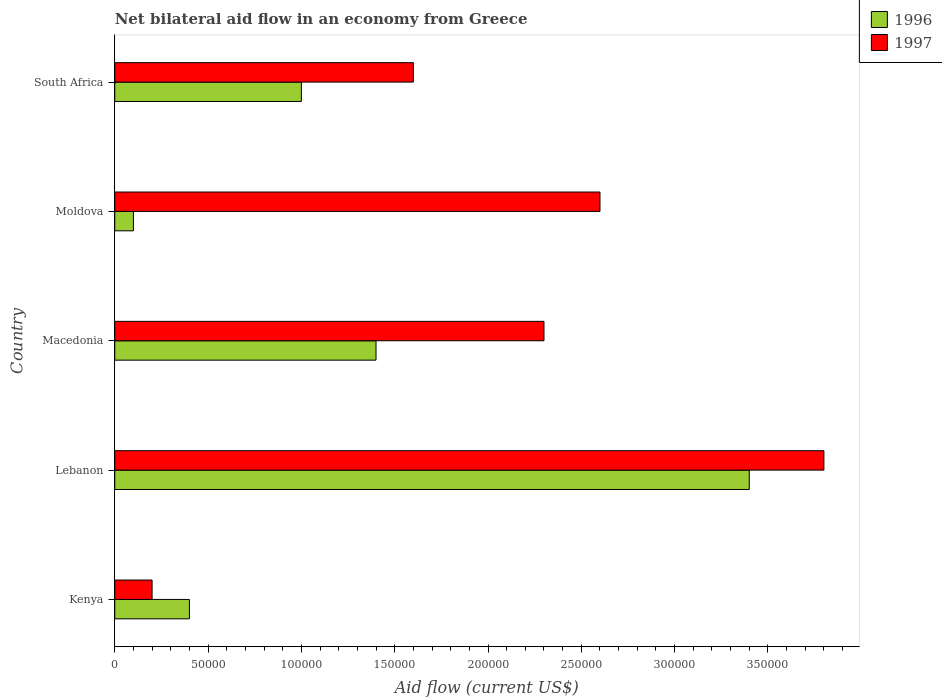How many groups of bars are there?
Your answer should be compact. 5. Are the number of bars per tick equal to the number of legend labels?
Offer a very short reply. Yes. What is the label of the 5th group of bars from the top?
Your response must be concise. Kenya. Across all countries, what is the minimum net bilateral aid flow in 1997?
Your answer should be very brief. 2.00e+04. In which country was the net bilateral aid flow in 1996 maximum?
Keep it short and to the point. Lebanon. In which country was the net bilateral aid flow in 1997 minimum?
Provide a short and direct response. Kenya. What is the total net bilateral aid flow in 1996 in the graph?
Your response must be concise. 6.30e+05. What is the difference between the net bilateral aid flow in 1996 in Kenya and that in Lebanon?
Your response must be concise. -3.00e+05. What is the average net bilateral aid flow in 1996 per country?
Provide a short and direct response. 1.26e+05. What is the difference between the net bilateral aid flow in 1996 and net bilateral aid flow in 1997 in Kenya?
Your answer should be compact. 2.00e+04. What is the ratio of the net bilateral aid flow in 1996 in Lebanon to that in Macedonia?
Provide a short and direct response. 2.43. Is the difference between the net bilateral aid flow in 1996 in Kenya and South Africa greater than the difference between the net bilateral aid flow in 1997 in Kenya and South Africa?
Offer a very short reply. Yes. What is the difference between the highest and the lowest net bilateral aid flow in 1996?
Provide a short and direct response. 3.30e+05. How many bars are there?
Offer a terse response. 10. Are all the bars in the graph horizontal?
Your response must be concise. Yes. How many countries are there in the graph?
Make the answer very short. 5. What is the difference between two consecutive major ticks on the X-axis?
Offer a very short reply. 5.00e+04. What is the title of the graph?
Provide a short and direct response. Net bilateral aid flow in an economy from Greece. Does "2005" appear as one of the legend labels in the graph?
Make the answer very short. No. What is the label or title of the X-axis?
Provide a succinct answer. Aid flow (current US$). What is the Aid flow (current US$) in 1996 in Kenya?
Offer a terse response. 4.00e+04. What is the Aid flow (current US$) in 1997 in Kenya?
Make the answer very short. 2.00e+04. What is the Aid flow (current US$) of 1996 in Lebanon?
Keep it short and to the point. 3.40e+05. What is the Aid flow (current US$) in 1997 in Lebanon?
Offer a very short reply. 3.80e+05. What is the Aid flow (current US$) of 1996 in Macedonia?
Your answer should be compact. 1.40e+05. What is the Aid flow (current US$) in 1997 in Macedonia?
Make the answer very short. 2.30e+05. What is the Aid flow (current US$) in 1996 in South Africa?
Your response must be concise. 1.00e+05. Across all countries, what is the maximum Aid flow (current US$) in 1997?
Provide a short and direct response. 3.80e+05. What is the total Aid flow (current US$) of 1996 in the graph?
Your answer should be very brief. 6.30e+05. What is the total Aid flow (current US$) in 1997 in the graph?
Make the answer very short. 1.05e+06. What is the difference between the Aid flow (current US$) in 1996 in Kenya and that in Lebanon?
Your answer should be very brief. -3.00e+05. What is the difference between the Aid flow (current US$) in 1997 in Kenya and that in Lebanon?
Give a very brief answer. -3.60e+05. What is the difference between the Aid flow (current US$) of 1996 in Kenya and that in Macedonia?
Keep it short and to the point. -1.00e+05. What is the difference between the Aid flow (current US$) in 1997 in Kenya and that in Macedonia?
Your answer should be very brief. -2.10e+05. What is the difference between the Aid flow (current US$) in 1996 in Kenya and that in Moldova?
Give a very brief answer. 3.00e+04. What is the difference between the Aid flow (current US$) of 1996 in Kenya and that in South Africa?
Offer a very short reply. -6.00e+04. What is the difference between the Aid flow (current US$) in 1997 in Kenya and that in South Africa?
Give a very brief answer. -1.40e+05. What is the difference between the Aid flow (current US$) in 1996 in Lebanon and that in Macedonia?
Your answer should be compact. 2.00e+05. What is the difference between the Aid flow (current US$) of 1996 in Lebanon and that in Moldova?
Your response must be concise. 3.30e+05. What is the difference between the Aid flow (current US$) in 1997 in Lebanon and that in Moldova?
Your answer should be very brief. 1.20e+05. What is the difference between the Aid flow (current US$) in 1997 in Lebanon and that in South Africa?
Provide a short and direct response. 2.20e+05. What is the difference between the Aid flow (current US$) of 1996 in Macedonia and that in Moldova?
Make the answer very short. 1.30e+05. What is the difference between the Aid flow (current US$) in 1996 in Moldova and that in South Africa?
Offer a terse response. -9.00e+04. What is the difference between the Aid flow (current US$) of 1996 in Kenya and the Aid flow (current US$) of 1997 in Lebanon?
Provide a short and direct response. -3.40e+05. What is the difference between the Aid flow (current US$) of 1996 in Kenya and the Aid flow (current US$) of 1997 in Macedonia?
Your answer should be compact. -1.90e+05. What is the difference between the Aid flow (current US$) in 1996 in Kenya and the Aid flow (current US$) in 1997 in Moldova?
Keep it short and to the point. -2.20e+05. What is the difference between the Aid flow (current US$) of 1996 in Kenya and the Aid flow (current US$) of 1997 in South Africa?
Your answer should be very brief. -1.20e+05. What is the difference between the Aid flow (current US$) of 1996 in Lebanon and the Aid flow (current US$) of 1997 in Macedonia?
Give a very brief answer. 1.10e+05. What is the difference between the Aid flow (current US$) in 1996 in Lebanon and the Aid flow (current US$) in 1997 in Moldova?
Your answer should be compact. 8.00e+04. What is the difference between the Aid flow (current US$) of 1996 in Lebanon and the Aid flow (current US$) of 1997 in South Africa?
Your answer should be very brief. 1.80e+05. What is the difference between the Aid flow (current US$) in 1996 in Macedonia and the Aid flow (current US$) in 1997 in South Africa?
Make the answer very short. -2.00e+04. What is the difference between the Aid flow (current US$) in 1996 in Moldova and the Aid flow (current US$) in 1997 in South Africa?
Your answer should be compact. -1.50e+05. What is the average Aid flow (current US$) of 1996 per country?
Provide a short and direct response. 1.26e+05. What is the difference between the Aid flow (current US$) in 1996 and Aid flow (current US$) in 1997 in Kenya?
Your answer should be very brief. 2.00e+04. What is the difference between the Aid flow (current US$) of 1996 and Aid flow (current US$) of 1997 in Macedonia?
Ensure brevity in your answer.  -9.00e+04. What is the difference between the Aid flow (current US$) of 1996 and Aid flow (current US$) of 1997 in South Africa?
Keep it short and to the point. -6.00e+04. What is the ratio of the Aid flow (current US$) in 1996 in Kenya to that in Lebanon?
Your response must be concise. 0.12. What is the ratio of the Aid flow (current US$) in 1997 in Kenya to that in Lebanon?
Make the answer very short. 0.05. What is the ratio of the Aid flow (current US$) in 1996 in Kenya to that in Macedonia?
Give a very brief answer. 0.29. What is the ratio of the Aid flow (current US$) in 1997 in Kenya to that in Macedonia?
Make the answer very short. 0.09. What is the ratio of the Aid flow (current US$) of 1997 in Kenya to that in Moldova?
Your answer should be very brief. 0.08. What is the ratio of the Aid flow (current US$) of 1996 in Kenya to that in South Africa?
Your response must be concise. 0.4. What is the ratio of the Aid flow (current US$) in 1996 in Lebanon to that in Macedonia?
Your answer should be compact. 2.43. What is the ratio of the Aid flow (current US$) in 1997 in Lebanon to that in Macedonia?
Offer a terse response. 1.65. What is the ratio of the Aid flow (current US$) of 1997 in Lebanon to that in Moldova?
Keep it short and to the point. 1.46. What is the ratio of the Aid flow (current US$) of 1997 in Lebanon to that in South Africa?
Your answer should be compact. 2.38. What is the ratio of the Aid flow (current US$) in 1996 in Macedonia to that in Moldova?
Offer a terse response. 14. What is the ratio of the Aid flow (current US$) of 1997 in Macedonia to that in Moldova?
Keep it short and to the point. 0.88. What is the ratio of the Aid flow (current US$) of 1996 in Macedonia to that in South Africa?
Keep it short and to the point. 1.4. What is the ratio of the Aid flow (current US$) of 1997 in Macedonia to that in South Africa?
Your answer should be compact. 1.44. What is the ratio of the Aid flow (current US$) in 1997 in Moldova to that in South Africa?
Ensure brevity in your answer.  1.62. What is the difference between the highest and the second highest Aid flow (current US$) of 1997?
Provide a short and direct response. 1.20e+05. What is the difference between the highest and the lowest Aid flow (current US$) in 1997?
Ensure brevity in your answer.  3.60e+05. 